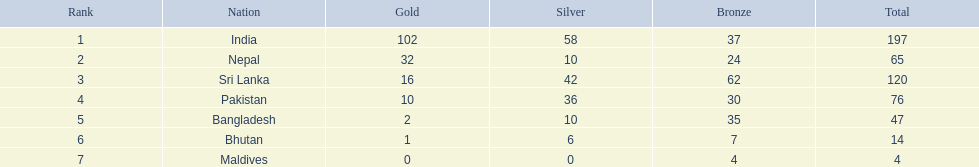What are all the countries listed in the table? India, Nepal, Sri Lanka, Pakistan, Bangladesh, Bhutan, Maldives. Which of these is not india? Nepal, Sri Lanka, Pakistan, Bangladesh, Bhutan, Maldives. Of these, which is first? Nepal. 